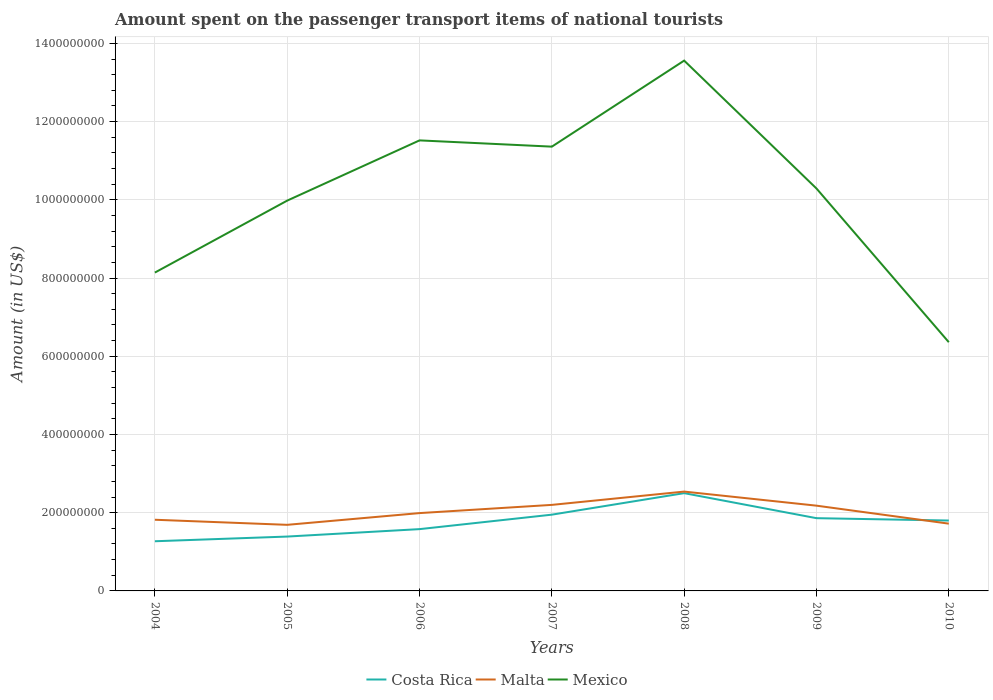Does the line corresponding to Malta intersect with the line corresponding to Costa Rica?
Offer a terse response. Yes. Across all years, what is the maximum amount spent on the passenger transport items of national tourists in Malta?
Your answer should be very brief. 1.69e+08. What is the total amount spent on the passenger transport items of national tourists in Costa Rica in the graph?
Ensure brevity in your answer.  -1.11e+08. What is the difference between the highest and the second highest amount spent on the passenger transport items of national tourists in Costa Rica?
Offer a very short reply. 1.23e+08. What is the difference between the highest and the lowest amount spent on the passenger transport items of national tourists in Malta?
Give a very brief answer. 3. How many lines are there?
Make the answer very short. 3. Are the values on the major ticks of Y-axis written in scientific E-notation?
Offer a very short reply. No. Where does the legend appear in the graph?
Your answer should be very brief. Bottom center. How are the legend labels stacked?
Your answer should be compact. Horizontal. What is the title of the graph?
Ensure brevity in your answer.  Amount spent on the passenger transport items of national tourists. Does "Mozambique" appear as one of the legend labels in the graph?
Your response must be concise. No. What is the label or title of the X-axis?
Offer a very short reply. Years. What is the Amount (in US$) of Costa Rica in 2004?
Your answer should be compact. 1.27e+08. What is the Amount (in US$) in Malta in 2004?
Provide a succinct answer. 1.82e+08. What is the Amount (in US$) of Mexico in 2004?
Your response must be concise. 8.14e+08. What is the Amount (in US$) in Costa Rica in 2005?
Make the answer very short. 1.39e+08. What is the Amount (in US$) of Malta in 2005?
Make the answer very short. 1.69e+08. What is the Amount (in US$) in Mexico in 2005?
Your answer should be very brief. 9.98e+08. What is the Amount (in US$) of Costa Rica in 2006?
Provide a short and direct response. 1.58e+08. What is the Amount (in US$) in Malta in 2006?
Provide a short and direct response. 1.99e+08. What is the Amount (in US$) in Mexico in 2006?
Offer a terse response. 1.15e+09. What is the Amount (in US$) of Costa Rica in 2007?
Your answer should be compact. 1.95e+08. What is the Amount (in US$) of Malta in 2007?
Offer a very short reply. 2.20e+08. What is the Amount (in US$) of Mexico in 2007?
Your answer should be compact. 1.14e+09. What is the Amount (in US$) of Costa Rica in 2008?
Give a very brief answer. 2.50e+08. What is the Amount (in US$) in Malta in 2008?
Provide a succinct answer. 2.54e+08. What is the Amount (in US$) in Mexico in 2008?
Give a very brief answer. 1.36e+09. What is the Amount (in US$) in Costa Rica in 2009?
Offer a terse response. 1.86e+08. What is the Amount (in US$) in Malta in 2009?
Offer a terse response. 2.18e+08. What is the Amount (in US$) in Mexico in 2009?
Make the answer very short. 1.03e+09. What is the Amount (in US$) in Costa Rica in 2010?
Offer a very short reply. 1.80e+08. What is the Amount (in US$) in Malta in 2010?
Keep it short and to the point. 1.72e+08. What is the Amount (in US$) in Mexico in 2010?
Make the answer very short. 6.36e+08. Across all years, what is the maximum Amount (in US$) of Costa Rica?
Offer a very short reply. 2.50e+08. Across all years, what is the maximum Amount (in US$) of Malta?
Provide a short and direct response. 2.54e+08. Across all years, what is the maximum Amount (in US$) of Mexico?
Your answer should be compact. 1.36e+09. Across all years, what is the minimum Amount (in US$) of Costa Rica?
Give a very brief answer. 1.27e+08. Across all years, what is the minimum Amount (in US$) in Malta?
Give a very brief answer. 1.69e+08. Across all years, what is the minimum Amount (in US$) of Mexico?
Provide a short and direct response. 6.36e+08. What is the total Amount (in US$) in Costa Rica in the graph?
Keep it short and to the point. 1.24e+09. What is the total Amount (in US$) of Malta in the graph?
Provide a succinct answer. 1.41e+09. What is the total Amount (in US$) of Mexico in the graph?
Your answer should be very brief. 7.12e+09. What is the difference between the Amount (in US$) in Costa Rica in 2004 and that in 2005?
Provide a succinct answer. -1.20e+07. What is the difference between the Amount (in US$) in Malta in 2004 and that in 2005?
Provide a succinct answer. 1.30e+07. What is the difference between the Amount (in US$) in Mexico in 2004 and that in 2005?
Give a very brief answer. -1.84e+08. What is the difference between the Amount (in US$) in Costa Rica in 2004 and that in 2006?
Give a very brief answer. -3.10e+07. What is the difference between the Amount (in US$) of Malta in 2004 and that in 2006?
Keep it short and to the point. -1.70e+07. What is the difference between the Amount (in US$) in Mexico in 2004 and that in 2006?
Your answer should be very brief. -3.38e+08. What is the difference between the Amount (in US$) in Costa Rica in 2004 and that in 2007?
Your response must be concise. -6.80e+07. What is the difference between the Amount (in US$) in Malta in 2004 and that in 2007?
Your response must be concise. -3.80e+07. What is the difference between the Amount (in US$) in Mexico in 2004 and that in 2007?
Provide a short and direct response. -3.22e+08. What is the difference between the Amount (in US$) of Costa Rica in 2004 and that in 2008?
Give a very brief answer. -1.23e+08. What is the difference between the Amount (in US$) in Malta in 2004 and that in 2008?
Make the answer very short. -7.20e+07. What is the difference between the Amount (in US$) of Mexico in 2004 and that in 2008?
Provide a short and direct response. -5.42e+08. What is the difference between the Amount (in US$) of Costa Rica in 2004 and that in 2009?
Ensure brevity in your answer.  -5.90e+07. What is the difference between the Amount (in US$) in Malta in 2004 and that in 2009?
Provide a succinct answer. -3.60e+07. What is the difference between the Amount (in US$) in Mexico in 2004 and that in 2009?
Provide a short and direct response. -2.15e+08. What is the difference between the Amount (in US$) of Costa Rica in 2004 and that in 2010?
Provide a short and direct response. -5.30e+07. What is the difference between the Amount (in US$) in Mexico in 2004 and that in 2010?
Provide a short and direct response. 1.78e+08. What is the difference between the Amount (in US$) in Costa Rica in 2005 and that in 2006?
Keep it short and to the point. -1.90e+07. What is the difference between the Amount (in US$) in Malta in 2005 and that in 2006?
Keep it short and to the point. -3.00e+07. What is the difference between the Amount (in US$) in Mexico in 2005 and that in 2006?
Provide a short and direct response. -1.54e+08. What is the difference between the Amount (in US$) of Costa Rica in 2005 and that in 2007?
Provide a short and direct response. -5.60e+07. What is the difference between the Amount (in US$) in Malta in 2005 and that in 2007?
Provide a short and direct response. -5.10e+07. What is the difference between the Amount (in US$) of Mexico in 2005 and that in 2007?
Your answer should be compact. -1.38e+08. What is the difference between the Amount (in US$) in Costa Rica in 2005 and that in 2008?
Provide a short and direct response. -1.11e+08. What is the difference between the Amount (in US$) in Malta in 2005 and that in 2008?
Your response must be concise. -8.50e+07. What is the difference between the Amount (in US$) in Mexico in 2005 and that in 2008?
Your answer should be very brief. -3.58e+08. What is the difference between the Amount (in US$) of Costa Rica in 2005 and that in 2009?
Provide a short and direct response. -4.70e+07. What is the difference between the Amount (in US$) in Malta in 2005 and that in 2009?
Offer a terse response. -4.90e+07. What is the difference between the Amount (in US$) of Mexico in 2005 and that in 2009?
Make the answer very short. -3.10e+07. What is the difference between the Amount (in US$) of Costa Rica in 2005 and that in 2010?
Your answer should be very brief. -4.10e+07. What is the difference between the Amount (in US$) in Malta in 2005 and that in 2010?
Make the answer very short. -3.00e+06. What is the difference between the Amount (in US$) in Mexico in 2005 and that in 2010?
Give a very brief answer. 3.62e+08. What is the difference between the Amount (in US$) of Costa Rica in 2006 and that in 2007?
Provide a succinct answer. -3.70e+07. What is the difference between the Amount (in US$) of Malta in 2006 and that in 2007?
Provide a succinct answer. -2.10e+07. What is the difference between the Amount (in US$) in Mexico in 2006 and that in 2007?
Your answer should be very brief. 1.60e+07. What is the difference between the Amount (in US$) in Costa Rica in 2006 and that in 2008?
Offer a terse response. -9.20e+07. What is the difference between the Amount (in US$) in Malta in 2006 and that in 2008?
Provide a succinct answer. -5.50e+07. What is the difference between the Amount (in US$) in Mexico in 2006 and that in 2008?
Your response must be concise. -2.04e+08. What is the difference between the Amount (in US$) of Costa Rica in 2006 and that in 2009?
Your answer should be compact. -2.80e+07. What is the difference between the Amount (in US$) of Malta in 2006 and that in 2009?
Provide a succinct answer. -1.90e+07. What is the difference between the Amount (in US$) of Mexico in 2006 and that in 2009?
Offer a very short reply. 1.23e+08. What is the difference between the Amount (in US$) of Costa Rica in 2006 and that in 2010?
Ensure brevity in your answer.  -2.20e+07. What is the difference between the Amount (in US$) in Malta in 2006 and that in 2010?
Provide a short and direct response. 2.70e+07. What is the difference between the Amount (in US$) of Mexico in 2006 and that in 2010?
Give a very brief answer. 5.16e+08. What is the difference between the Amount (in US$) of Costa Rica in 2007 and that in 2008?
Your answer should be compact. -5.50e+07. What is the difference between the Amount (in US$) of Malta in 2007 and that in 2008?
Your answer should be very brief. -3.40e+07. What is the difference between the Amount (in US$) in Mexico in 2007 and that in 2008?
Give a very brief answer. -2.20e+08. What is the difference between the Amount (in US$) in Costa Rica in 2007 and that in 2009?
Offer a terse response. 9.00e+06. What is the difference between the Amount (in US$) in Mexico in 2007 and that in 2009?
Your answer should be compact. 1.07e+08. What is the difference between the Amount (in US$) of Costa Rica in 2007 and that in 2010?
Ensure brevity in your answer.  1.50e+07. What is the difference between the Amount (in US$) of Malta in 2007 and that in 2010?
Offer a very short reply. 4.80e+07. What is the difference between the Amount (in US$) of Mexico in 2007 and that in 2010?
Ensure brevity in your answer.  5.00e+08. What is the difference between the Amount (in US$) of Costa Rica in 2008 and that in 2009?
Provide a succinct answer. 6.40e+07. What is the difference between the Amount (in US$) in Malta in 2008 and that in 2009?
Your answer should be very brief. 3.60e+07. What is the difference between the Amount (in US$) of Mexico in 2008 and that in 2009?
Keep it short and to the point. 3.27e+08. What is the difference between the Amount (in US$) of Costa Rica in 2008 and that in 2010?
Give a very brief answer. 7.00e+07. What is the difference between the Amount (in US$) of Malta in 2008 and that in 2010?
Give a very brief answer. 8.20e+07. What is the difference between the Amount (in US$) in Mexico in 2008 and that in 2010?
Offer a very short reply. 7.20e+08. What is the difference between the Amount (in US$) of Malta in 2009 and that in 2010?
Provide a short and direct response. 4.60e+07. What is the difference between the Amount (in US$) in Mexico in 2009 and that in 2010?
Provide a short and direct response. 3.93e+08. What is the difference between the Amount (in US$) in Costa Rica in 2004 and the Amount (in US$) in Malta in 2005?
Make the answer very short. -4.20e+07. What is the difference between the Amount (in US$) of Costa Rica in 2004 and the Amount (in US$) of Mexico in 2005?
Offer a very short reply. -8.71e+08. What is the difference between the Amount (in US$) of Malta in 2004 and the Amount (in US$) of Mexico in 2005?
Keep it short and to the point. -8.16e+08. What is the difference between the Amount (in US$) of Costa Rica in 2004 and the Amount (in US$) of Malta in 2006?
Your answer should be compact. -7.20e+07. What is the difference between the Amount (in US$) in Costa Rica in 2004 and the Amount (in US$) in Mexico in 2006?
Your response must be concise. -1.02e+09. What is the difference between the Amount (in US$) of Malta in 2004 and the Amount (in US$) of Mexico in 2006?
Offer a very short reply. -9.70e+08. What is the difference between the Amount (in US$) of Costa Rica in 2004 and the Amount (in US$) of Malta in 2007?
Your response must be concise. -9.30e+07. What is the difference between the Amount (in US$) of Costa Rica in 2004 and the Amount (in US$) of Mexico in 2007?
Offer a terse response. -1.01e+09. What is the difference between the Amount (in US$) in Malta in 2004 and the Amount (in US$) in Mexico in 2007?
Ensure brevity in your answer.  -9.54e+08. What is the difference between the Amount (in US$) of Costa Rica in 2004 and the Amount (in US$) of Malta in 2008?
Provide a short and direct response. -1.27e+08. What is the difference between the Amount (in US$) of Costa Rica in 2004 and the Amount (in US$) of Mexico in 2008?
Give a very brief answer. -1.23e+09. What is the difference between the Amount (in US$) in Malta in 2004 and the Amount (in US$) in Mexico in 2008?
Offer a very short reply. -1.17e+09. What is the difference between the Amount (in US$) of Costa Rica in 2004 and the Amount (in US$) of Malta in 2009?
Offer a very short reply. -9.10e+07. What is the difference between the Amount (in US$) of Costa Rica in 2004 and the Amount (in US$) of Mexico in 2009?
Your response must be concise. -9.02e+08. What is the difference between the Amount (in US$) in Malta in 2004 and the Amount (in US$) in Mexico in 2009?
Offer a very short reply. -8.47e+08. What is the difference between the Amount (in US$) in Costa Rica in 2004 and the Amount (in US$) in Malta in 2010?
Make the answer very short. -4.50e+07. What is the difference between the Amount (in US$) in Costa Rica in 2004 and the Amount (in US$) in Mexico in 2010?
Your answer should be compact. -5.09e+08. What is the difference between the Amount (in US$) of Malta in 2004 and the Amount (in US$) of Mexico in 2010?
Give a very brief answer. -4.54e+08. What is the difference between the Amount (in US$) in Costa Rica in 2005 and the Amount (in US$) in Malta in 2006?
Make the answer very short. -6.00e+07. What is the difference between the Amount (in US$) in Costa Rica in 2005 and the Amount (in US$) in Mexico in 2006?
Make the answer very short. -1.01e+09. What is the difference between the Amount (in US$) of Malta in 2005 and the Amount (in US$) of Mexico in 2006?
Provide a short and direct response. -9.83e+08. What is the difference between the Amount (in US$) in Costa Rica in 2005 and the Amount (in US$) in Malta in 2007?
Offer a very short reply. -8.10e+07. What is the difference between the Amount (in US$) of Costa Rica in 2005 and the Amount (in US$) of Mexico in 2007?
Keep it short and to the point. -9.97e+08. What is the difference between the Amount (in US$) of Malta in 2005 and the Amount (in US$) of Mexico in 2007?
Make the answer very short. -9.67e+08. What is the difference between the Amount (in US$) in Costa Rica in 2005 and the Amount (in US$) in Malta in 2008?
Offer a terse response. -1.15e+08. What is the difference between the Amount (in US$) of Costa Rica in 2005 and the Amount (in US$) of Mexico in 2008?
Your answer should be very brief. -1.22e+09. What is the difference between the Amount (in US$) in Malta in 2005 and the Amount (in US$) in Mexico in 2008?
Your answer should be very brief. -1.19e+09. What is the difference between the Amount (in US$) of Costa Rica in 2005 and the Amount (in US$) of Malta in 2009?
Ensure brevity in your answer.  -7.90e+07. What is the difference between the Amount (in US$) of Costa Rica in 2005 and the Amount (in US$) of Mexico in 2009?
Give a very brief answer. -8.90e+08. What is the difference between the Amount (in US$) in Malta in 2005 and the Amount (in US$) in Mexico in 2009?
Offer a very short reply. -8.60e+08. What is the difference between the Amount (in US$) of Costa Rica in 2005 and the Amount (in US$) of Malta in 2010?
Provide a short and direct response. -3.30e+07. What is the difference between the Amount (in US$) in Costa Rica in 2005 and the Amount (in US$) in Mexico in 2010?
Provide a succinct answer. -4.97e+08. What is the difference between the Amount (in US$) of Malta in 2005 and the Amount (in US$) of Mexico in 2010?
Your answer should be very brief. -4.67e+08. What is the difference between the Amount (in US$) in Costa Rica in 2006 and the Amount (in US$) in Malta in 2007?
Offer a very short reply. -6.20e+07. What is the difference between the Amount (in US$) of Costa Rica in 2006 and the Amount (in US$) of Mexico in 2007?
Keep it short and to the point. -9.78e+08. What is the difference between the Amount (in US$) in Malta in 2006 and the Amount (in US$) in Mexico in 2007?
Provide a short and direct response. -9.37e+08. What is the difference between the Amount (in US$) of Costa Rica in 2006 and the Amount (in US$) of Malta in 2008?
Give a very brief answer. -9.60e+07. What is the difference between the Amount (in US$) in Costa Rica in 2006 and the Amount (in US$) in Mexico in 2008?
Provide a short and direct response. -1.20e+09. What is the difference between the Amount (in US$) in Malta in 2006 and the Amount (in US$) in Mexico in 2008?
Provide a succinct answer. -1.16e+09. What is the difference between the Amount (in US$) of Costa Rica in 2006 and the Amount (in US$) of Malta in 2009?
Ensure brevity in your answer.  -6.00e+07. What is the difference between the Amount (in US$) in Costa Rica in 2006 and the Amount (in US$) in Mexico in 2009?
Your answer should be compact. -8.71e+08. What is the difference between the Amount (in US$) of Malta in 2006 and the Amount (in US$) of Mexico in 2009?
Provide a succinct answer. -8.30e+08. What is the difference between the Amount (in US$) of Costa Rica in 2006 and the Amount (in US$) of Malta in 2010?
Your answer should be very brief. -1.40e+07. What is the difference between the Amount (in US$) of Costa Rica in 2006 and the Amount (in US$) of Mexico in 2010?
Your answer should be compact. -4.78e+08. What is the difference between the Amount (in US$) in Malta in 2006 and the Amount (in US$) in Mexico in 2010?
Offer a very short reply. -4.37e+08. What is the difference between the Amount (in US$) in Costa Rica in 2007 and the Amount (in US$) in Malta in 2008?
Provide a succinct answer. -5.90e+07. What is the difference between the Amount (in US$) of Costa Rica in 2007 and the Amount (in US$) of Mexico in 2008?
Ensure brevity in your answer.  -1.16e+09. What is the difference between the Amount (in US$) of Malta in 2007 and the Amount (in US$) of Mexico in 2008?
Offer a terse response. -1.14e+09. What is the difference between the Amount (in US$) of Costa Rica in 2007 and the Amount (in US$) of Malta in 2009?
Ensure brevity in your answer.  -2.30e+07. What is the difference between the Amount (in US$) of Costa Rica in 2007 and the Amount (in US$) of Mexico in 2009?
Your answer should be compact. -8.34e+08. What is the difference between the Amount (in US$) in Malta in 2007 and the Amount (in US$) in Mexico in 2009?
Keep it short and to the point. -8.09e+08. What is the difference between the Amount (in US$) of Costa Rica in 2007 and the Amount (in US$) of Malta in 2010?
Offer a terse response. 2.30e+07. What is the difference between the Amount (in US$) of Costa Rica in 2007 and the Amount (in US$) of Mexico in 2010?
Keep it short and to the point. -4.41e+08. What is the difference between the Amount (in US$) of Malta in 2007 and the Amount (in US$) of Mexico in 2010?
Make the answer very short. -4.16e+08. What is the difference between the Amount (in US$) in Costa Rica in 2008 and the Amount (in US$) in Malta in 2009?
Give a very brief answer. 3.20e+07. What is the difference between the Amount (in US$) in Costa Rica in 2008 and the Amount (in US$) in Mexico in 2009?
Make the answer very short. -7.79e+08. What is the difference between the Amount (in US$) in Malta in 2008 and the Amount (in US$) in Mexico in 2009?
Ensure brevity in your answer.  -7.75e+08. What is the difference between the Amount (in US$) in Costa Rica in 2008 and the Amount (in US$) in Malta in 2010?
Your response must be concise. 7.80e+07. What is the difference between the Amount (in US$) of Costa Rica in 2008 and the Amount (in US$) of Mexico in 2010?
Keep it short and to the point. -3.86e+08. What is the difference between the Amount (in US$) in Malta in 2008 and the Amount (in US$) in Mexico in 2010?
Your answer should be very brief. -3.82e+08. What is the difference between the Amount (in US$) of Costa Rica in 2009 and the Amount (in US$) of Malta in 2010?
Give a very brief answer. 1.40e+07. What is the difference between the Amount (in US$) in Costa Rica in 2009 and the Amount (in US$) in Mexico in 2010?
Ensure brevity in your answer.  -4.50e+08. What is the difference between the Amount (in US$) of Malta in 2009 and the Amount (in US$) of Mexico in 2010?
Keep it short and to the point. -4.18e+08. What is the average Amount (in US$) of Costa Rica per year?
Your answer should be very brief. 1.76e+08. What is the average Amount (in US$) in Malta per year?
Provide a succinct answer. 2.02e+08. What is the average Amount (in US$) in Mexico per year?
Offer a very short reply. 1.02e+09. In the year 2004, what is the difference between the Amount (in US$) of Costa Rica and Amount (in US$) of Malta?
Provide a succinct answer. -5.50e+07. In the year 2004, what is the difference between the Amount (in US$) of Costa Rica and Amount (in US$) of Mexico?
Keep it short and to the point. -6.87e+08. In the year 2004, what is the difference between the Amount (in US$) of Malta and Amount (in US$) of Mexico?
Ensure brevity in your answer.  -6.32e+08. In the year 2005, what is the difference between the Amount (in US$) in Costa Rica and Amount (in US$) in Malta?
Make the answer very short. -3.00e+07. In the year 2005, what is the difference between the Amount (in US$) in Costa Rica and Amount (in US$) in Mexico?
Provide a succinct answer. -8.59e+08. In the year 2005, what is the difference between the Amount (in US$) in Malta and Amount (in US$) in Mexico?
Provide a succinct answer. -8.29e+08. In the year 2006, what is the difference between the Amount (in US$) in Costa Rica and Amount (in US$) in Malta?
Ensure brevity in your answer.  -4.10e+07. In the year 2006, what is the difference between the Amount (in US$) in Costa Rica and Amount (in US$) in Mexico?
Your response must be concise. -9.94e+08. In the year 2006, what is the difference between the Amount (in US$) in Malta and Amount (in US$) in Mexico?
Your answer should be compact. -9.53e+08. In the year 2007, what is the difference between the Amount (in US$) of Costa Rica and Amount (in US$) of Malta?
Your response must be concise. -2.50e+07. In the year 2007, what is the difference between the Amount (in US$) in Costa Rica and Amount (in US$) in Mexico?
Your answer should be very brief. -9.41e+08. In the year 2007, what is the difference between the Amount (in US$) of Malta and Amount (in US$) of Mexico?
Make the answer very short. -9.16e+08. In the year 2008, what is the difference between the Amount (in US$) of Costa Rica and Amount (in US$) of Malta?
Ensure brevity in your answer.  -4.00e+06. In the year 2008, what is the difference between the Amount (in US$) of Costa Rica and Amount (in US$) of Mexico?
Offer a very short reply. -1.11e+09. In the year 2008, what is the difference between the Amount (in US$) in Malta and Amount (in US$) in Mexico?
Provide a succinct answer. -1.10e+09. In the year 2009, what is the difference between the Amount (in US$) of Costa Rica and Amount (in US$) of Malta?
Your response must be concise. -3.20e+07. In the year 2009, what is the difference between the Amount (in US$) of Costa Rica and Amount (in US$) of Mexico?
Give a very brief answer. -8.43e+08. In the year 2009, what is the difference between the Amount (in US$) of Malta and Amount (in US$) of Mexico?
Offer a terse response. -8.11e+08. In the year 2010, what is the difference between the Amount (in US$) in Costa Rica and Amount (in US$) in Mexico?
Offer a very short reply. -4.56e+08. In the year 2010, what is the difference between the Amount (in US$) in Malta and Amount (in US$) in Mexico?
Give a very brief answer. -4.64e+08. What is the ratio of the Amount (in US$) in Costa Rica in 2004 to that in 2005?
Make the answer very short. 0.91. What is the ratio of the Amount (in US$) of Mexico in 2004 to that in 2005?
Make the answer very short. 0.82. What is the ratio of the Amount (in US$) of Costa Rica in 2004 to that in 2006?
Offer a terse response. 0.8. What is the ratio of the Amount (in US$) in Malta in 2004 to that in 2006?
Ensure brevity in your answer.  0.91. What is the ratio of the Amount (in US$) of Mexico in 2004 to that in 2006?
Keep it short and to the point. 0.71. What is the ratio of the Amount (in US$) in Costa Rica in 2004 to that in 2007?
Offer a very short reply. 0.65. What is the ratio of the Amount (in US$) of Malta in 2004 to that in 2007?
Your answer should be very brief. 0.83. What is the ratio of the Amount (in US$) of Mexico in 2004 to that in 2007?
Provide a succinct answer. 0.72. What is the ratio of the Amount (in US$) of Costa Rica in 2004 to that in 2008?
Your answer should be very brief. 0.51. What is the ratio of the Amount (in US$) of Malta in 2004 to that in 2008?
Ensure brevity in your answer.  0.72. What is the ratio of the Amount (in US$) of Mexico in 2004 to that in 2008?
Keep it short and to the point. 0.6. What is the ratio of the Amount (in US$) of Costa Rica in 2004 to that in 2009?
Make the answer very short. 0.68. What is the ratio of the Amount (in US$) of Malta in 2004 to that in 2009?
Provide a short and direct response. 0.83. What is the ratio of the Amount (in US$) in Mexico in 2004 to that in 2009?
Ensure brevity in your answer.  0.79. What is the ratio of the Amount (in US$) in Costa Rica in 2004 to that in 2010?
Provide a short and direct response. 0.71. What is the ratio of the Amount (in US$) of Malta in 2004 to that in 2010?
Your response must be concise. 1.06. What is the ratio of the Amount (in US$) of Mexico in 2004 to that in 2010?
Your answer should be compact. 1.28. What is the ratio of the Amount (in US$) in Costa Rica in 2005 to that in 2006?
Ensure brevity in your answer.  0.88. What is the ratio of the Amount (in US$) of Malta in 2005 to that in 2006?
Your answer should be compact. 0.85. What is the ratio of the Amount (in US$) in Mexico in 2005 to that in 2006?
Your response must be concise. 0.87. What is the ratio of the Amount (in US$) of Costa Rica in 2005 to that in 2007?
Make the answer very short. 0.71. What is the ratio of the Amount (in US$) of Malta in 2005 to that in 2007?
Provide a succinct answer. 0.77. What is the ratio of the Amount (in US$) in Mexico in 2005 to that in 2007?
Give a very brief answer. 0.88. What is the ratio of the Amount (in US$) in Costa Rica in 2005 to that in 2008?
Provide a succinct answer. 0.56. What is the ratio of the Amount (in US$) in Malta in 2005 to that in 2008?
Make the answer very short. 0.67. What is the ratio of the Amount (in US$) of Mexico in 2005 to that in 2008?
Offer a terse response. 0.74. What is the ratio of the Amount (in US$) of Costa Rica in 2005 to that in 2009?
Ensure brevity in your answer.  0.75. What is the ratio of the Amount (in US$) of Malta in 2005 to that in 2009?
Your response must be concise. 0.78. What is the ratio of the Amount (in US$) of Mexico in 2005 to that in 2009?
Offer a very short reply. 0.97. What is the ratio of the Amount (in US$) of Costa Rica in 2005 to that in 2010?
Your answer should be compact. 0.77. What is the ratio of the Amount (in US$) of Malta in 2005 to that in 2010?
Make the answer very short. 0.98. What is the ratio of the Amount (in US$) in Mexico in 2005 to that in 2010?
Offer a terse response. 1.57. What is the ratio of the Amount (in US$) of Costa Rica in 2006 to that in 2007?
Your answer should be compact. 0.81. What is the ratio of the Amount (in US$) in Malta in 2006 to that in 2007?
Your response must be concise. 0.9. What is the ratio of the Amount (in US$) of Mexico in 2006 to that in 2007?
Offer a very short reply. 1.01. What is the ratio of the Amount (in US$) in Costa Rica in 2006 to that in 2008?
Give a very brief answer. 0.63. What is the ratio of the Amount (in US$) in Malta in 2006 to that in 2008?
Keep it short and to the point. 0.78. What is the ratio of the Amount (in US$) of Mexico in 2006 to that in 2008?
Your answer should be very brief. 0.85. What is the ratio of the Amount (in US$) of Costa Rica in 2006 to that in 2009?
Offer a very short reply. 0.85. What is the ratio of the Amount (in US$) in Malta in 2006 to that in 2009?
Your response must be concise. 0.91. What is the ratio of the Amount (in US$) in Mexico in 2006 to that in 2009?
Offer a terse response. 1.12. What is the ratio of the Amount (in US$) in Costa Rica in 2006 to that in 2010?
Ensure brevity in your answer.  0.88. What is the ratio of the Amount (in US$) in Malta in 2006 to that in 2010?
Provide a succinct answer. 1.16. What is the ratio of the Amount (in US$) in Mexico in 2006 to that in 2010?
Offer a terse response. 1.81. What is the ratio of the Amount (in US$) of Costa Rica in 2007 to that in 2008?
Offer a terse response. 0.78. What is the ratio of the Amount (in US$) in Malta in 2007 to that in 2008?
Offer a very short reply. 0.87. What is the ratio of the Amount (in US$) in Mexico in 2007 to that in 2008?
Ensure brevity in your answer.  0.84. What is the ratio of the Amount (in US$) in Costa Rica in 2007 to that in 2009?
Provide a short and direct response. 1.05. What is the ratio of the Amount (in US$) in Malta in 2007 to that in 2009?
Provide a succinct answer. 1.01. What is the ratio of the Amount (in US$) in Mexico in 2007 to that in 2009?
Your response must be concise. 1.1. What is the ratio of the Amount (in US$) of Costa Rica in 2007 to that in 2010?
Your answer should be compact. 1.08. What is the ratio of the Amount (in US$) in Malta in 2007 to that in 2010?
Your response must be concise. 1.28. What is the ratio of the Amount (in US$) in Mexico in 2007 to that in 2010?
Ensure brevity in your answer.  1.79. What is the ratio of the Amount (in US$) of Costa Rica in 2008 to that in 2009?
Offer a very short reply. 1.34. What is the ratio of the Amount (in US$) in Malta in 2008 to that in 2009?
Make the answer very short. 1.17. What is the ratio of the Amount (in US$) in Mexico in 2008 to that in 2009?
Provide a short and direct response. 1.32. What is the ratio of the Amount (in US$) in Costa Rica in 2008 to that in 2010?
Provide a succinct answer. 1.39. What is the ratio of the Amount (in US$) in Malta in 2008 to that in 2010?
Give a very brief answer. 1.48. What is the ratio of the Amount (in US$) of Mexico in 2008 to that in 2010?
Your response must be concise. 2.13. What is the ratio of the Amount (in US$) of Malta in 2009 to that in 2010?
Offer a terse response. 1.27. What is the ratio of the Amount (in US$) in Mexico in 2009 to that in 2010?
Provide a short and direct response. 1.62. What is the difference between the highest and the second highest Amount (in US$) in Costa Rica?
Ensure brevity in your answer.  5.50e+07. What is the difference between the highest and the second highest Amount (in US$) of Malta?
Keep it short and to the point. 3.40e+07. What is the difference between the highest and the second highest Amount (in US$) of Mexico?
Make the answer very short. 2.04e+08. What is the difference between the highest and the lowest Amount (in US$) in Costa Rica?
Provide a short and direct response. 1.23e+08. What is the difference between the highest and the lowest Amount (in US$) in Malta?
Provide a short and direct response. 8.50e+07. What is the difference between the highest and the lowest Amount (in US$) in Mexico?
Offer a very short reply. 7.20e+08. 